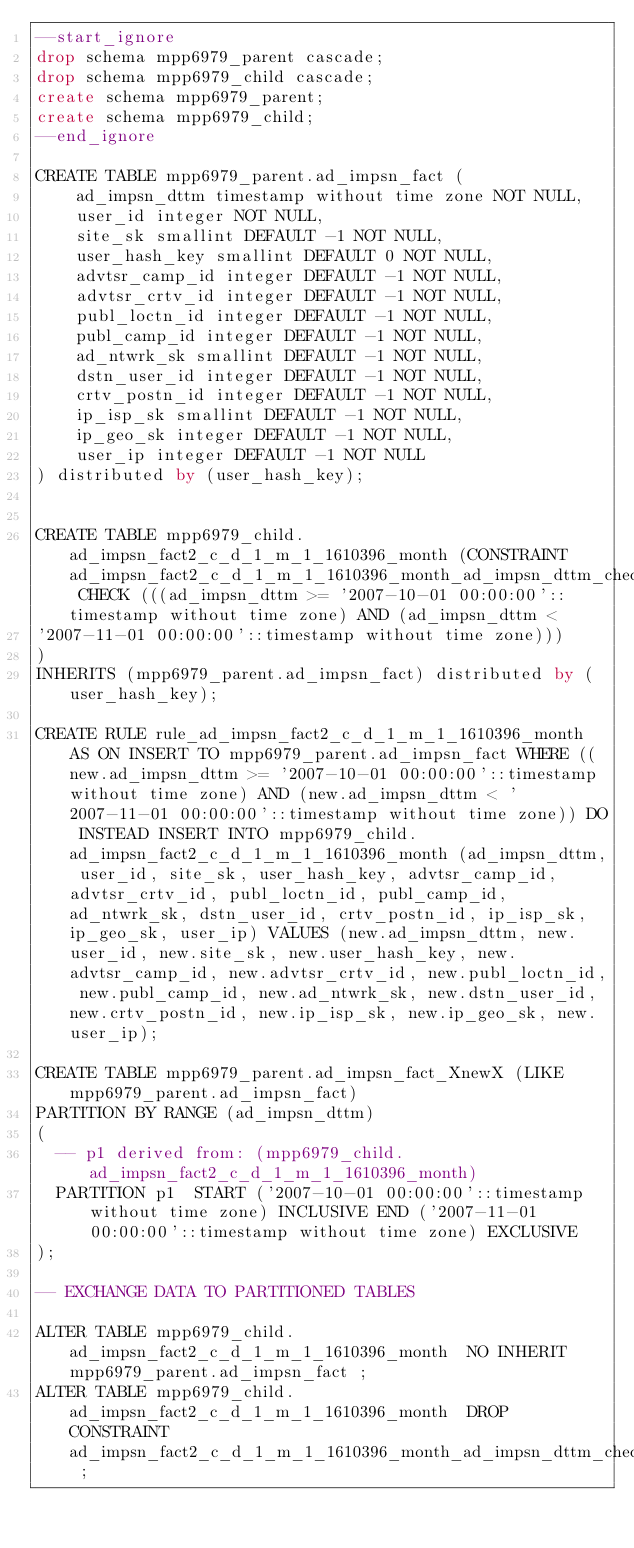Convert code to text. <code><loc_0><loc_0><loc_500><loc_500><_SQL_>--start_ignore
drop schema mpp6979_parent cascade;
drop schema mpp6979_child cascade;
create schema mpp6979_parent;
create schema mpp6979_child;
--end_ignore

CREATE TABLE mpp6979_parent.ad_impsn_fact (
    ad_impsn_dttm timestamp without time zone NOT NULL,
    user_id integer NOT NULL,
    site_sk smallint DEFAULT -1 NOT NULL,
    user_hash_key smallint DEFAULT 0 NOT NULL,
    advtsr_camp_id integer DEFAULT -1 NOT NULL,
    advtsr_crtv_id integer DEFAULT -1 NOT NULL,
    publ_loctn_id integer DEFAULT -1 NOT NULL,
    publ_camp_id integer DEFAULT -1 NOT NULL,
    ad_ntwrk_sk smallint DEFAULT -1 NOT NULL,
    dstn_user_id integer DEFAULT -1 NOT NULL,
    crtv_postn_id integer DEFAULT -1 NOT NULL,
    ip_isp_sk smallint DEFAULT -1 NOT NULL,
    ip_geo_sk integer DEFAULT -1 NOT NULL,
    user_ip integer DEFAULT -1 NOT NULL
) distributed by (user_hash_key);


CREATE TABLE mpp6979_child.ad_impsn_fact2_c_d_1_m_1_1610396_month (CONSTRAINT ad_impsn_fact2_c_d_1_m_1_1610396_month_ad_impsn_dttm_check CHECK (((ad_impsn_dttm >= '2007-10-01 00:00:00'::timestamp without time zone) AND (ad_impsn_dttm <
'2007-11-01 00:00:00'::timestamp without time zone)))
)
INHERITS (mpp6979_parent.ad_impsn_fact) distributed by (user_hash_key);

CREATE RULE rule_ad_impsn_fact2_c_d_1_m_1_1610396_month AS ON INSERT TO mpp6979_parent.ad_impsn_fact WHERE ((new.ad_impsn_dttm >= '2007-10-01 00:00:00'::timestamp without time zone) AND (new.ad_impsn_dttm < '2007-11-01 00:00:00'::timestamp without time zone)) DO INSTEAD INSERT INTO mpp6979_child.ad_impsn_fact2_c_d_1_m_1_1610396_month (ad_impsn_dttm, user_id, site_sk, user_hash_key, advtsr_camp_id, advtsr_crtv_id, publ_loctn_id, publ_camp_id, ad_ntwrk_sk, dstn_user_id, crtv_postn_id, ip_isp_sk, ip_geo_sk, user_ip) VALUES (new.ad_impsn_dttm, new.user_id, new.site_sk, new.user_hash_key, new.advtsr_camp_id, new.advtsr_crtv_id, new.publ_loctn_id, new.publ_camp_id, new.ad_ntwrk_sk, new.dstn_user_id, new.crtv_postn_id, new.ip_isp_sk, new.ip_geo_sk, new.user_ip);

CREATE TABLE mpp6979_parent.ad_impsn_fact_XnewX (LIKE mpp6979_parent.ad_impsn_fact)
PARTITION BY RANGE (ad_impsn_dttm)
(
  -- p1 derived from: (mpp6979_child.ad_impsn_fact2_c_d_1_m_1_1610396_month)
  PARTITION p1  START ('2007-10-01 00:00:00'::timestamp without time zone) INCLUSIVE END ('2007-11-01 00:00:00'::timestamp without time zone) EXCLUSIVE
);

-- EXCHANGE DATA TO PARTITIONED TABLES

ALTER TABLE mpp6979_child.ad_impsn_fact2_c_d_1_m_1_1610396_month  NO INHERIT mpp6979_parent.ad_impsn_fact ;
ALTER TABLE mpp6979_child.ad_impsn_fact2_c_d_1_m_1_1610396_month  DROP CONSTRAINT ad_impsn_fact2_c_d_1_m_1_1610396_month_ad_impsn_dttm_check ;</code> 